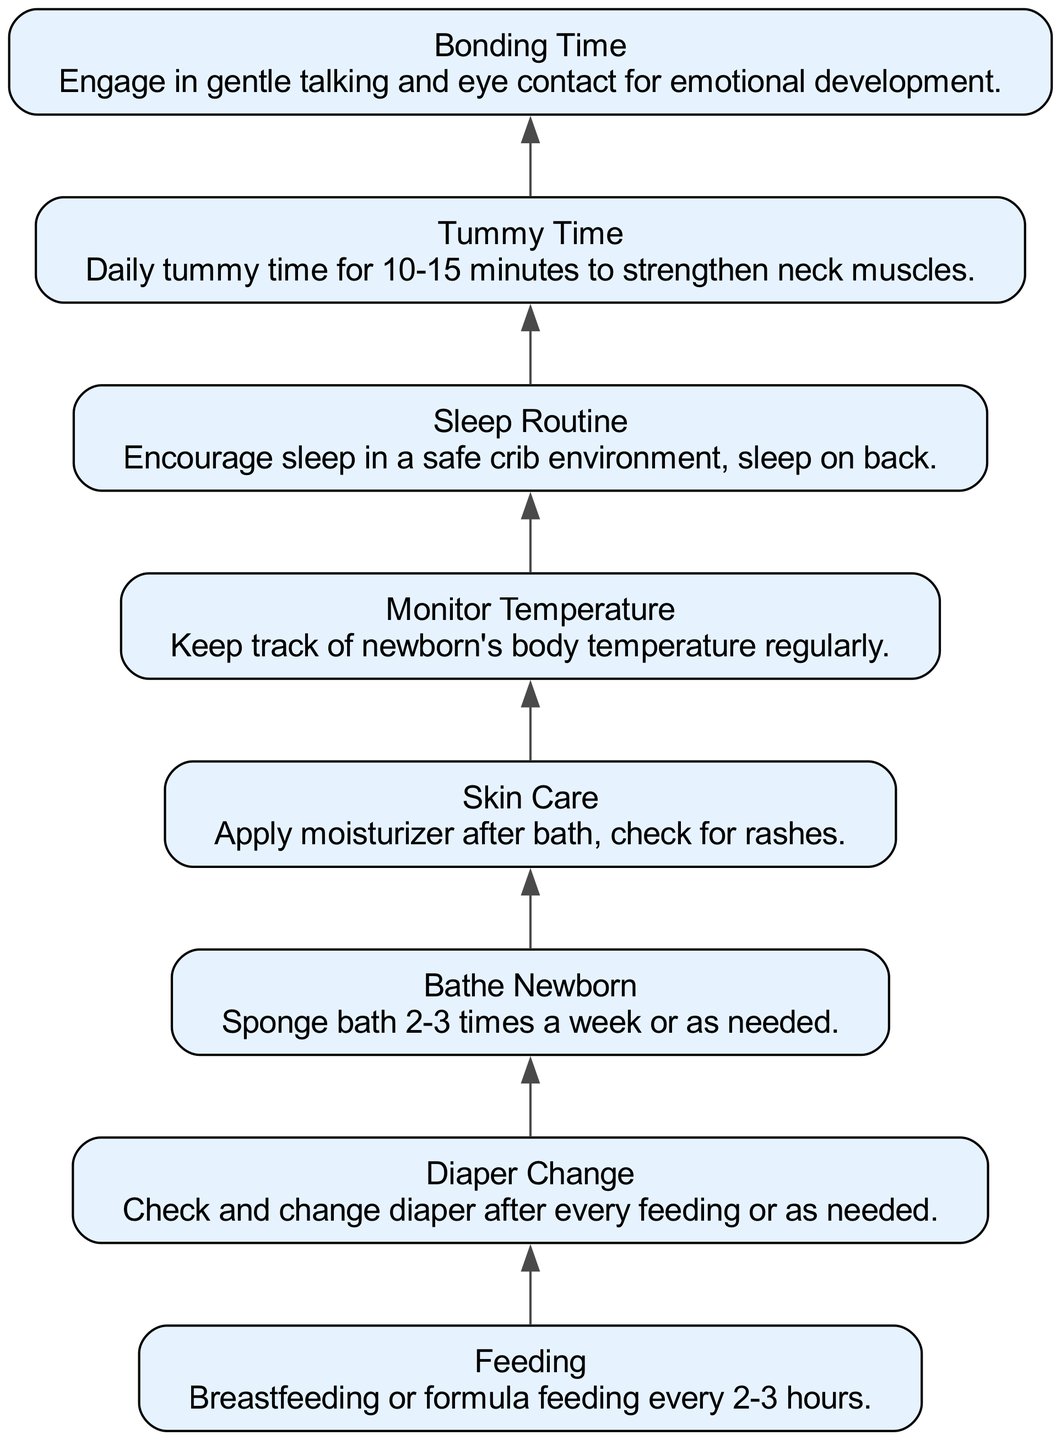What is the first step in the daily routine structure for newborn care? The first step is "Feeding," which is the initial activity before moving to diaper change.
Answer: Feeding How many nodes are in the diagram? There are a total of 8 nodes present, each representing a different aspect of newborn care.
Answer: 8 What comes after "Diaper Change"? The process progresses from "Diaper Change" to "Bathe Newborn," indicating the next activity after changing the diaper.
Answer: Bathe Newborn What is the last step in the daily routine structure? The last step, following all other activities, is "Bonding Time," which promotes emotional development.
Answer: Bonding Time Which activity involves strengthening neck muscles? "Tummy Time" is specifically designed for strengthening the neck muscles of the newborn.
Answer: Tummy Time What is the relationship between "Skin Care" and "Monitor Temperature"? "Skin Care" directly leads to "Monitor Temperature," indicating that they are sequential activities in the routine.
Answer: Monitor Temperature How many activities include a specific health monitoring aspect? There are two activities that involve health monitoring: "Monitor Temperature" and "Diaper Change."
Answer: 2 Which two activities are connected through one edge in the flow chart? "Bathe Newborn" and "Skin Care" are connected through one edge, representing a direct transition from one to the other.
Answer: Bathe Newborn and Skin Care What is the primary purpose of "Bonding Time"? The primary purpose of "Bonding Time" is to engage in gentle talking and eye contact for emotional development.
Answer: Emotional development 